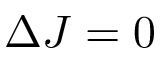<formula> <loc_0><loc_0><loc_500><loc_500>\Delta J = 0</formula> 